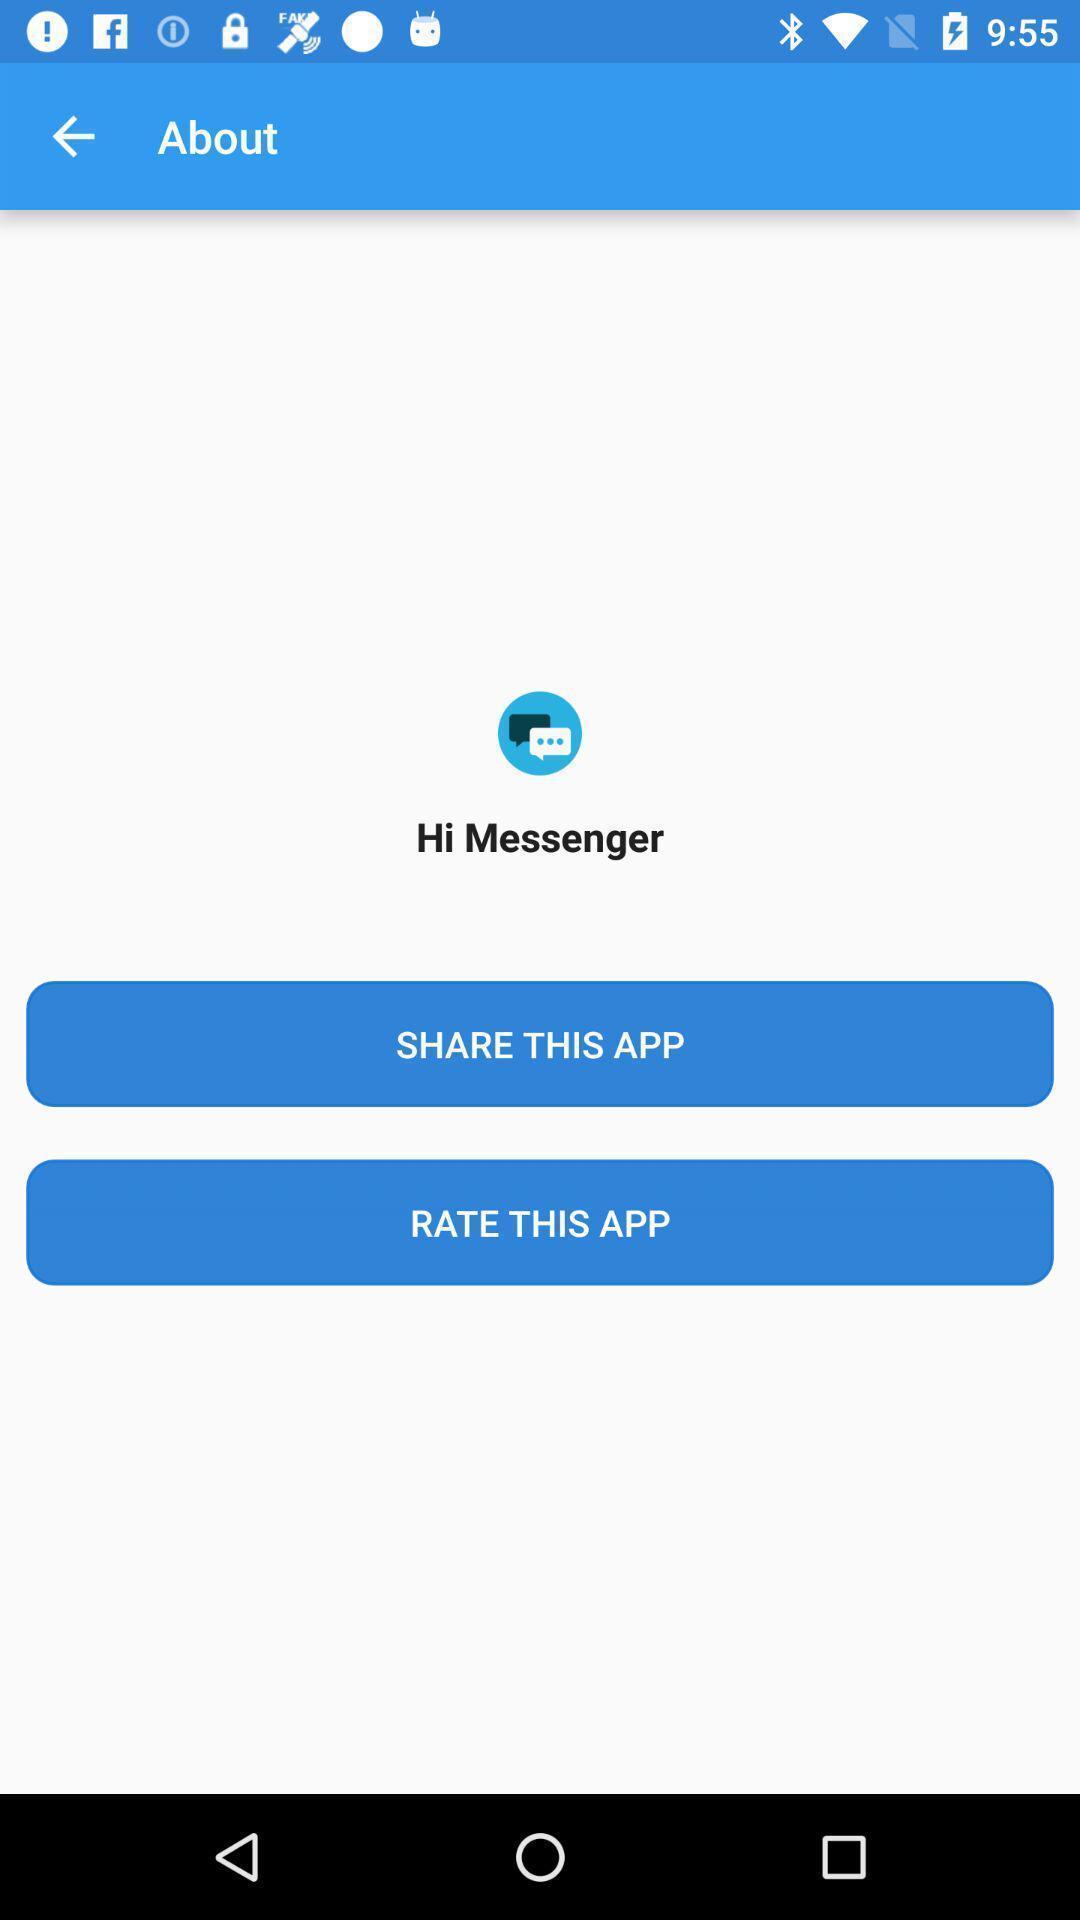Describe the visual elements of this screenshot. Screen shows to share the app. 